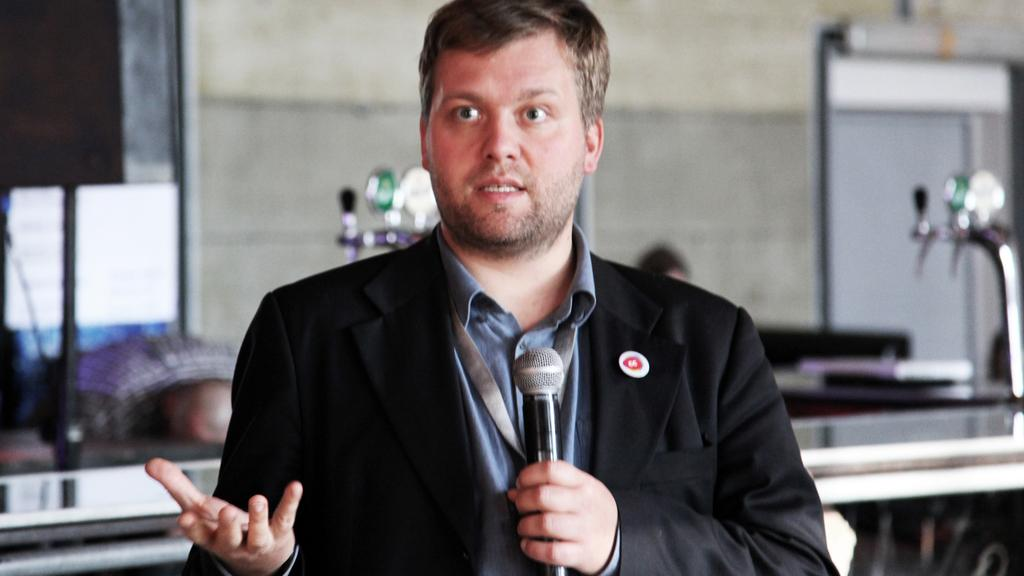What is the man wearing in the image? The man is wearing a black suit in the image. What object is the man holding in the image? The man is holding a microphone in the image. Can you describe the background of the image? The background of the image is blurry. What is the man doing with the microphone? The man is speaking in front of the microphone in the image. Is the man wearing a silk shirt under his black suit in the image? There is no information about the type of shirt the man is wearing under his black suit in the image. 